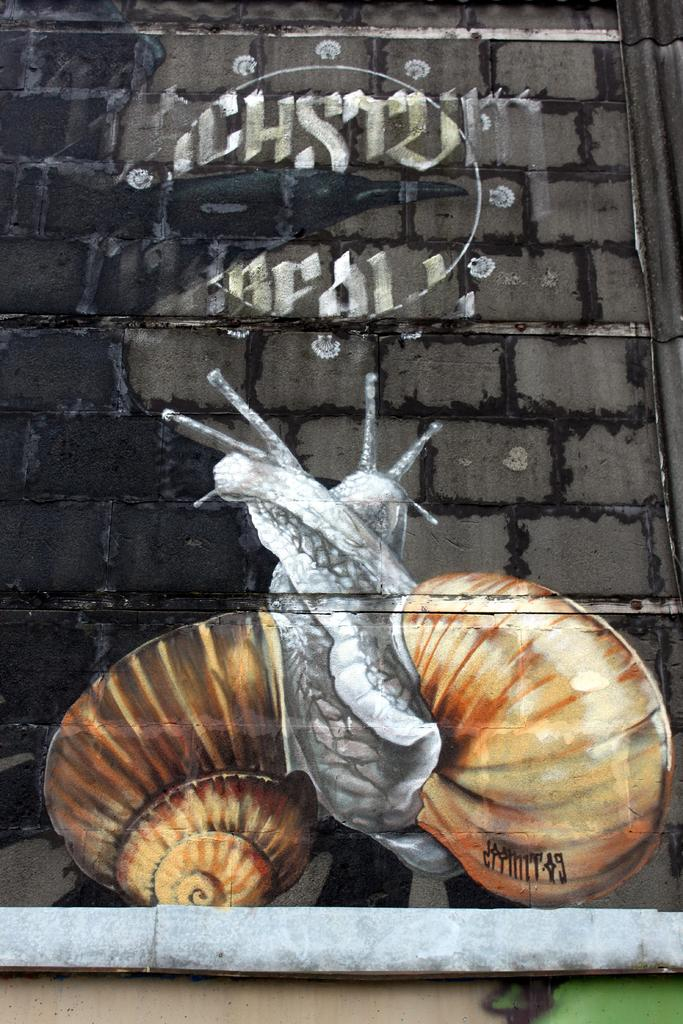What is present on the wall in the image? There is a painting on the wall. What is the subject of the painting? The painting depicts a snail. What else can be seen in the image besides the wall and painting? There is a pipe in the image. What offer is being made by the snail in the painting? The painting does not depict a snail making an offer; it simply shows a snail. What part of the machine can be seen in the image? There is no machine present in the image. 